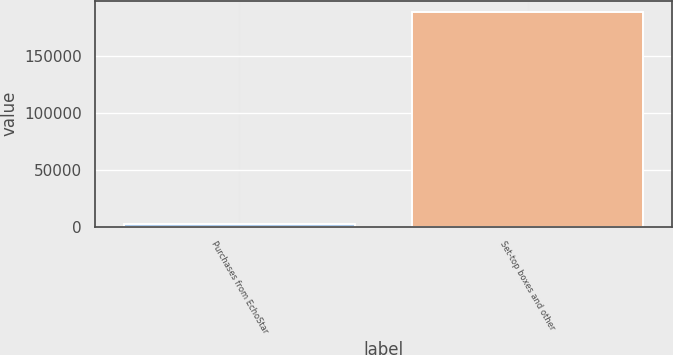Convert chart to OTSL. <chart><loc_0><loc_0><loc_500><loc_500><bar_chart><fcel>Purchases from EchoStar<fcel>Set-top boxes and other<nl><fcel>2009<fcel>188793<nl></chart> 